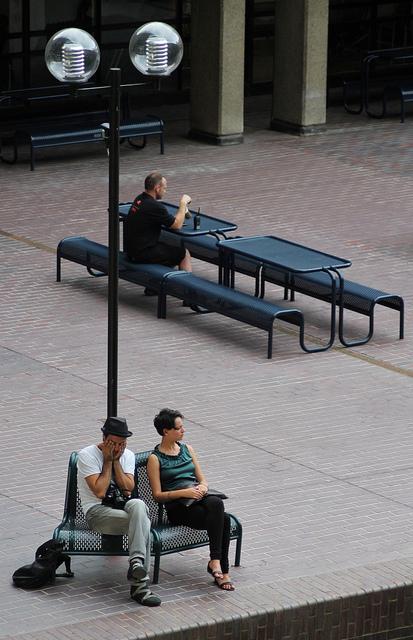What are the people sitting on?
Concise answer only. Bench. Are the two men talking to each other?
Short answer required. No. What material is the bench and table made of?
Concise answer only. Metal. 